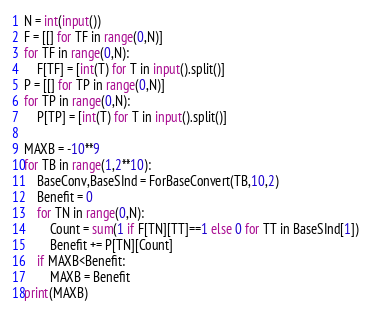Convert code to text. <code><loc_0><loc_0><loc_500><loc_500><_Python_>N = int(input())
F = [[] for TF in range(0,N)]
for TF in range(0,N):
    F[TF] = [int(T) for T in input().split()]
P = [[] for TP in range(0,N)]
for TP in range(0,N):
    P[TP] = [int(T) for T in input().split()]
    
MAXB = -10**9
for TB in range(1,2**10):
    BaseConv,BaseSInd = ForBaseConvert(TB,10,2)
    Benefit = 0
    for TN in range(0,N):        
        Count = sum(1 if F[TN][TT]==1 else 0 for TT in BaseSInd[1])
        Benefit += P[TN][Count]
    if MAXB<Benefit:
        MAXB = Benefit
print(MAXB)</code> 